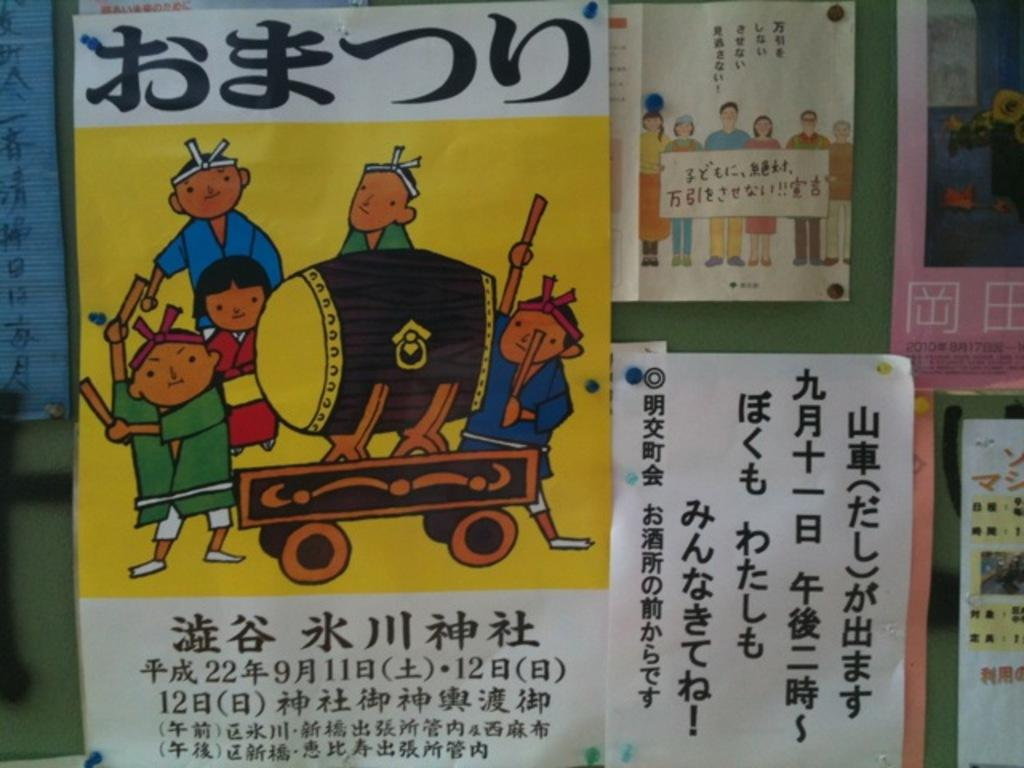What is present on the notice board in the image? There are posters on a notice board in the image. How many types of posters can be seen on the notice board? The posters are of different types. What type of behavior is being discussed in the image? There is no discussion or behavior present in the image; it only features posters on a notice board. 